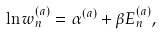<formula> <loc_0><loc_0><loc_500><loc_500>\ln w ^ { ( a ) } _ { n } = \alpha ^ { ( a ) } + \beta E ^ { ( a ) } _ { n } ,</formula> 